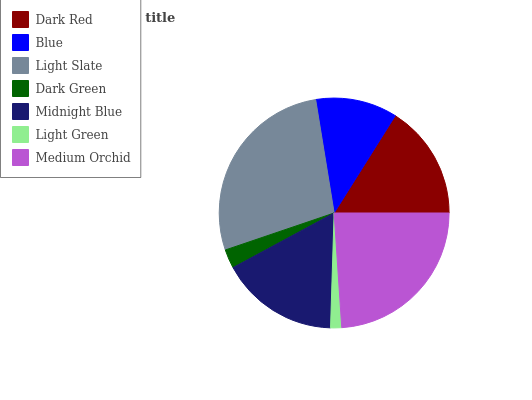Is Light Green the minimum?
Answer yes or no. Yes. Is Light Slate the maximum?
Answer yes or no. Yes. Is Blue the minimum?
Answer yes or no. No. Is Blue the maximum?
Answer yes or no. No. Is Dark Red greater than Blue?
Answer yes or no. Yes. Is Blue less than Dark Red?
Answer yes or no. Yes. Is Blue greater than Dark Red?
Answer yes or no. No. Is Dark Red less than Blue?
Answer yes or no. No. Is Dark Red the high median?
Answer yes or no. Yes. Is Dark Red the low median?
Answer yes or no. Yes. Is Dark Green the high median?
Answer yes or no. No. Is Light Green the low median?
Answer yes or no. No. 